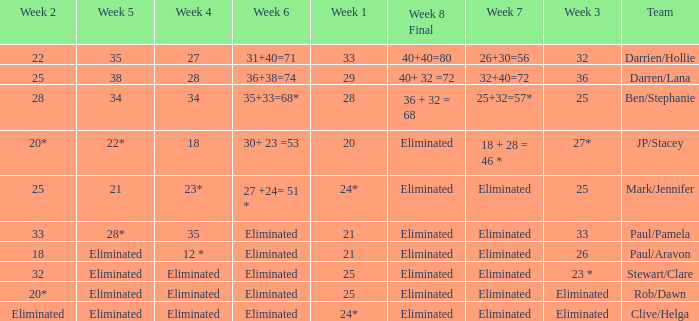Name the team for week 1 of 28 Ben/Stephanie. 